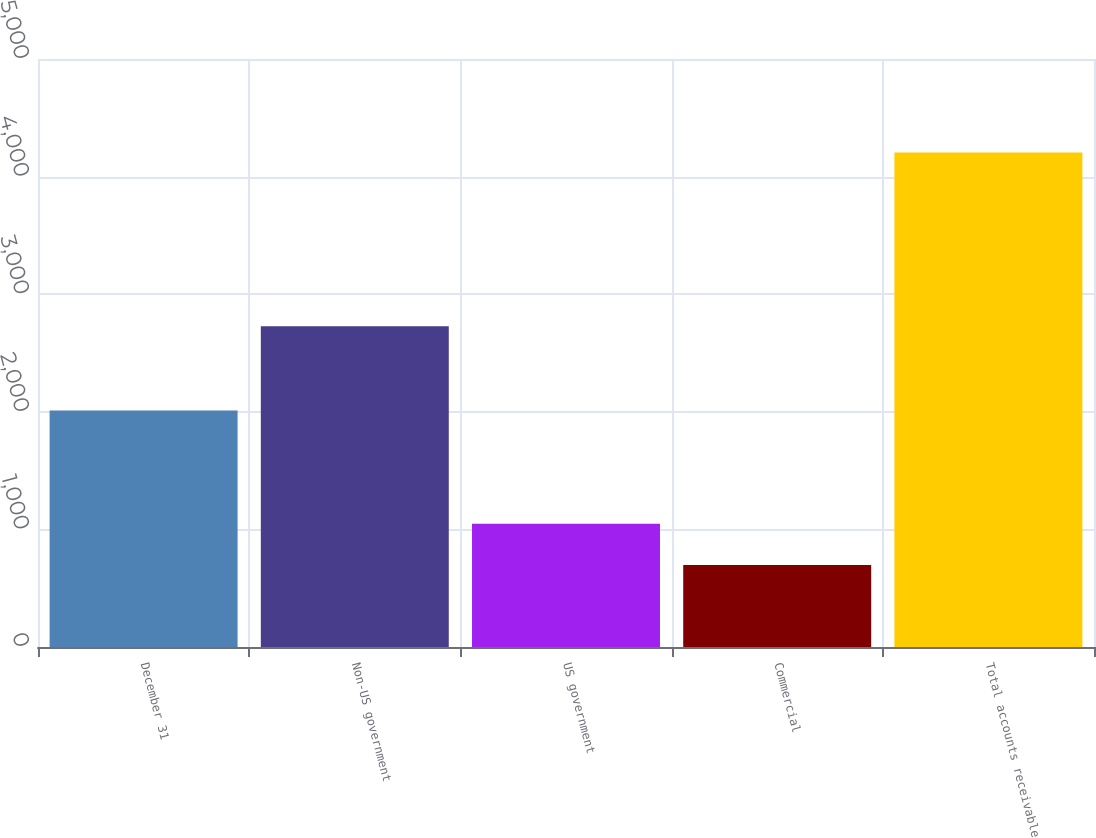<chart> <loc_0><loc_0><loc_500><loc_500><bar_chart><fcel>December 31<fcel>Non-US government<fcel>US government<fcel>Commercial<fcel>Total accounts receivable<nl><fcel>2012<fcel>2728<fcel>1048.6<fcel>698<fcel>4204<nl></chart> 